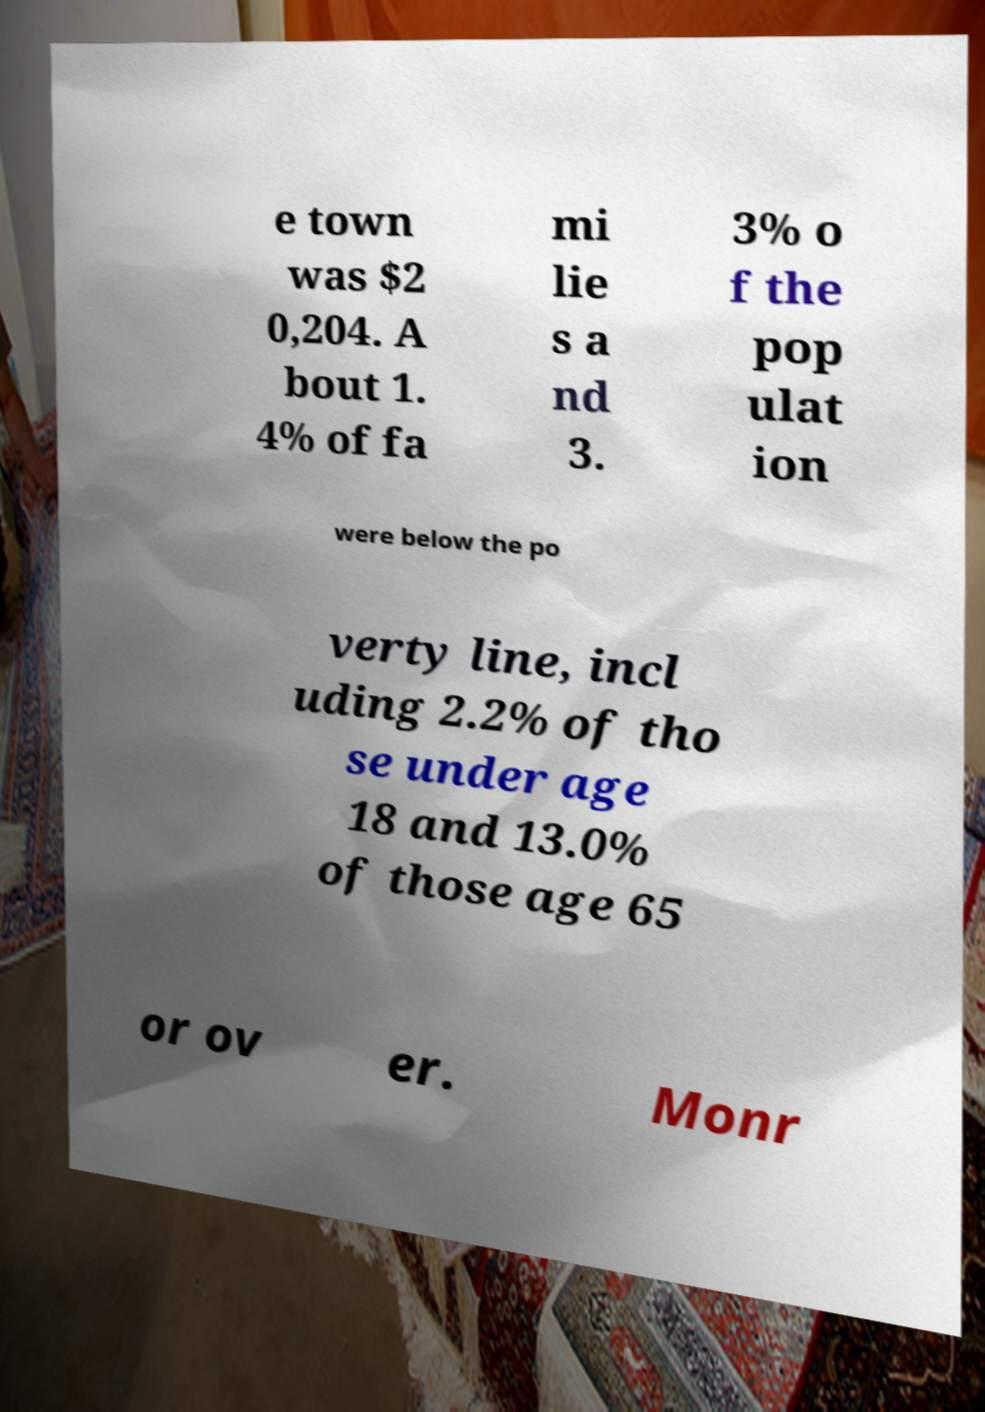Please read and relay the text visible in this image. What does it say? e town was $2 0,204. A bout 1. 4% of fa mi lie s a nd 3. 3% o f the pop ulat ion were below the po verty line, incl uding 2.2% of tho se under age 18 and 13.0% of those age 65 or ov er. Monr 